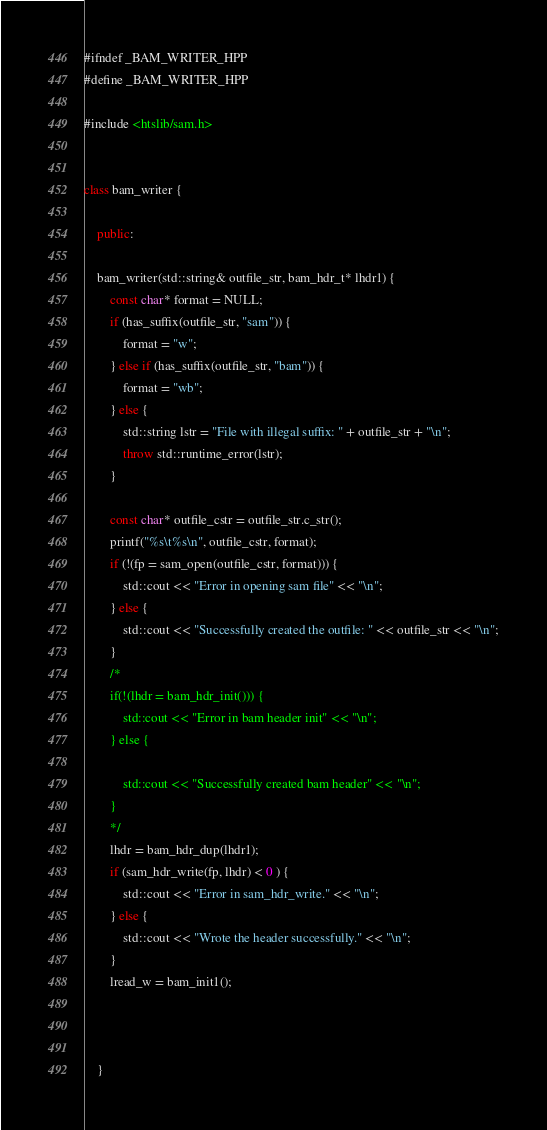<code> <loc_0><loc_0><loc_500><loc_500><_C++_>#ifndef _BAM_WRITER_HPP
#define _BAM_WRITER_HPP

#include <htslib/sam.h>


class bam_writer {

    public:

    bam_writer(std::string& outfile_str, bam_hdr_t* lhdr1) {
        const char* format = NULL;
        if (has_suffix(outfile_str, "sam")) {
            format = "w";
        } else if (has_suffix(outfile_str, "bam")) {
            format = "wb";
        } else {
            std::string lstr = "File with illegal suffix: " + outfile_str + "\n";
            throw std::runtime_error(lstr);
        }

        const char* outfile_cstr = outfile_str.c_str();
        printf("%s\t%s\n", outfile_cstr, format);
        if (!(fp = sam_open(outfile_cstr, format))) {
            std::cout << "Error in opening sam file" << "\n";
        } else {
            std::cout << "Successfully created the outfile: " << outfile_str << "\n";
        }
        /*
        if(!(lhdr = bam_hdr_init())) {
            std::cout << "Error in bam header init" << "\n";
        } else {
        
            std::cout << "Successfully created bam header" << "\n";
        }
        */
        lhdr = bam_hdr_dup(lhdr1);
        if (sam_hdr_write(fp, lhdr) < 0 ) {
            std::cout << "Error in sam_hdr_write." << "\n";
        } else {
            std::cout << "Wrote the header successfully." << "\n";
        }
        lread_w = bam_init1();



    }
</code> 